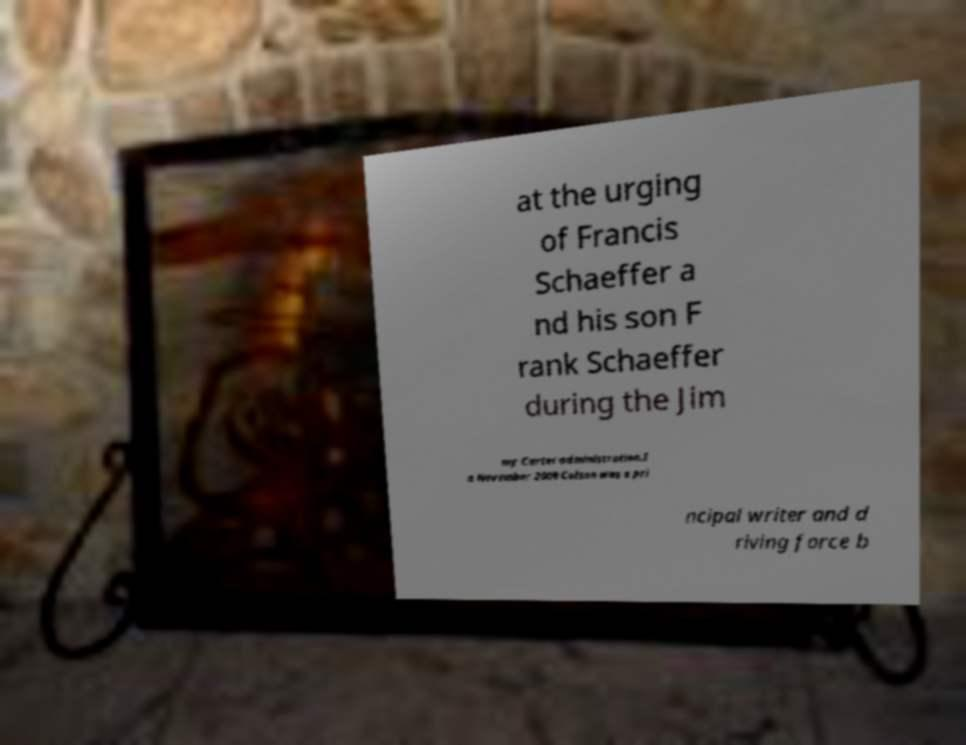What messages or text are displayed in this image? I need them in a readable, typed format. at the urging of Francis Schaeffer a nd his son F rank Schaeffer during the Jim my Carter administration.I n November 2009 Colson was a pri ncipal writer and d riving force b 